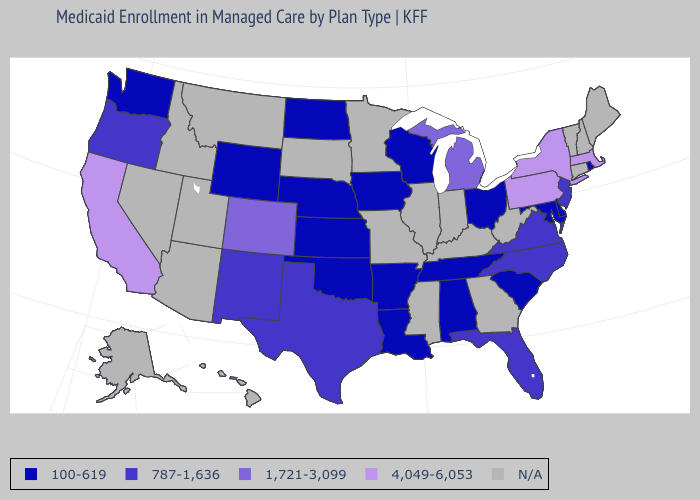Among the states that border Alabama , which have the highest value?
Concise answer only. Florida. Does the map have missing data?
Answer briefly. Yes. Among the states that border Alabama , does Florida have the highest value?
Concise answer only. Yes. Name the states that have a value in the range 4,049-6,053?
Be succinct. California, Massachusetts, New York, Pennsylvania. Name the states that have a value in the range 100-619?
Answer briefly. Alabama, Arkansas, Delaware, Iowa, Kansas, Louisiana, Maryland, Nebraska, North Dakota, Ohio, Oklahoma, Rhode Island, South Carolina, Tennessee, Washington, Wisconsin, Wyoming. Does New Jersey have the lowest value in the USA?
Quick response, please. No. What is the value of Michigan?
Short answer required. 1,721-3,099. What is the value of Montana?
Answer briefly. N/A. What is the lowest value in the USA?
Concise answer only. 100-619. Which states have the lowest value in the Northeast?
Keep it brief. Rhode Island. Name the states that have a value in the range 787-1,636?
Give a very brief answer. Florida, New Jersey, New Mexico, North Carolina, Oregon, Texas, Virginia. Among the states that border Alabama , which have the highest value?
Short answer required. Florida. Which states have the lowest value in the West?
Concise answer only. Washington, Wyoming. 